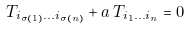<formula> <loc_0><loc_0><loc_500><loc_500>T _ { i _ { \sigma ( 1 ) } \dots i _ { \sigma ( n ) } } + a \, T _ { i _ { 1 } \dots i _ { n } } = 0</formula> 